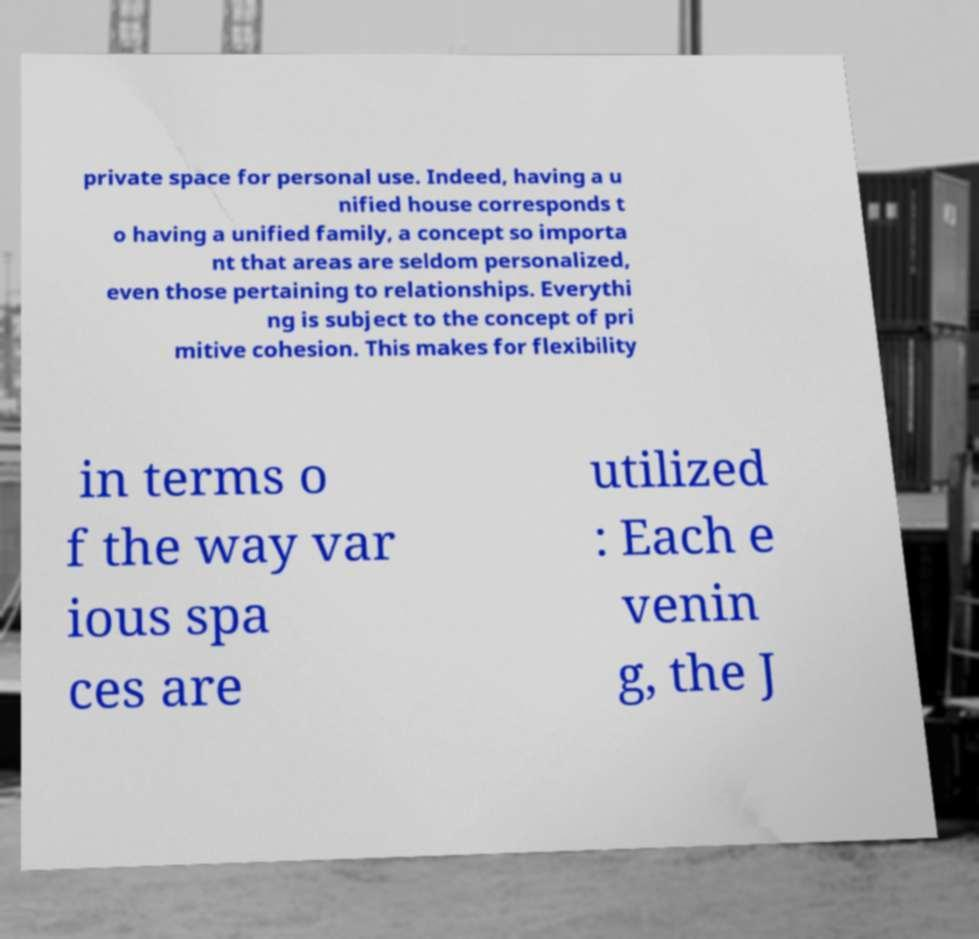Please identify and transcribe the text found in this image. private space for personal use. Indeed, having a u nified house corresponds t o having a unified family, a concept so importa nt that areas are seldom personalized, even those pertaining to relationships. Everythi ng is subject to the concept of pri mitive cohesion. This makes for flexibility in terms o f the way var ious spa ces are utilized : Each e venin g, the J 